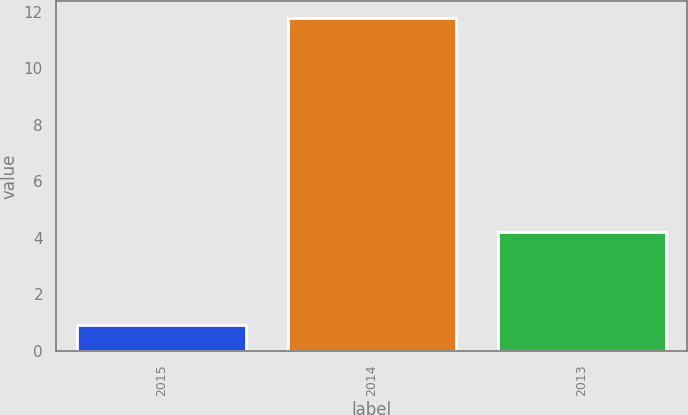Convert chart to OTSL. <chart><loc_0><loc_0><loc_500><loc_500><bar_chart><fcel>2015<fcel>2014<fcel>2013<nl><fcel>0.9<fcel>11.8<fcel>4.2<nl></chart> 